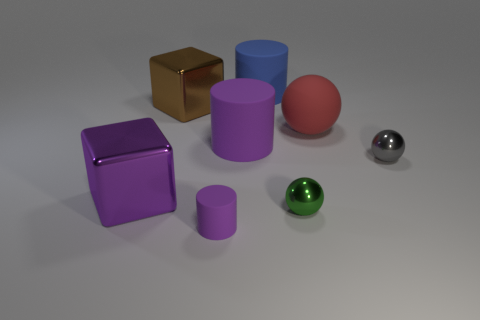Subtract all brown spheres. How many purple cylinders are left? 2 Add 2 gray metal cubes. How many objects exist? 10 Subtract all spheres. How many objects are left? 5 Subtract 0 gray cylinders. How many objects are left? 8 Subtract all big brown blocks. Subtract all big blue rubber things. How many objects are left? 6 Add 5 small gray spheres. How many small gray spheres are left? 6 Add 5 tiny cyan matte objects. How many tiny cyan matte objects exist? 5 